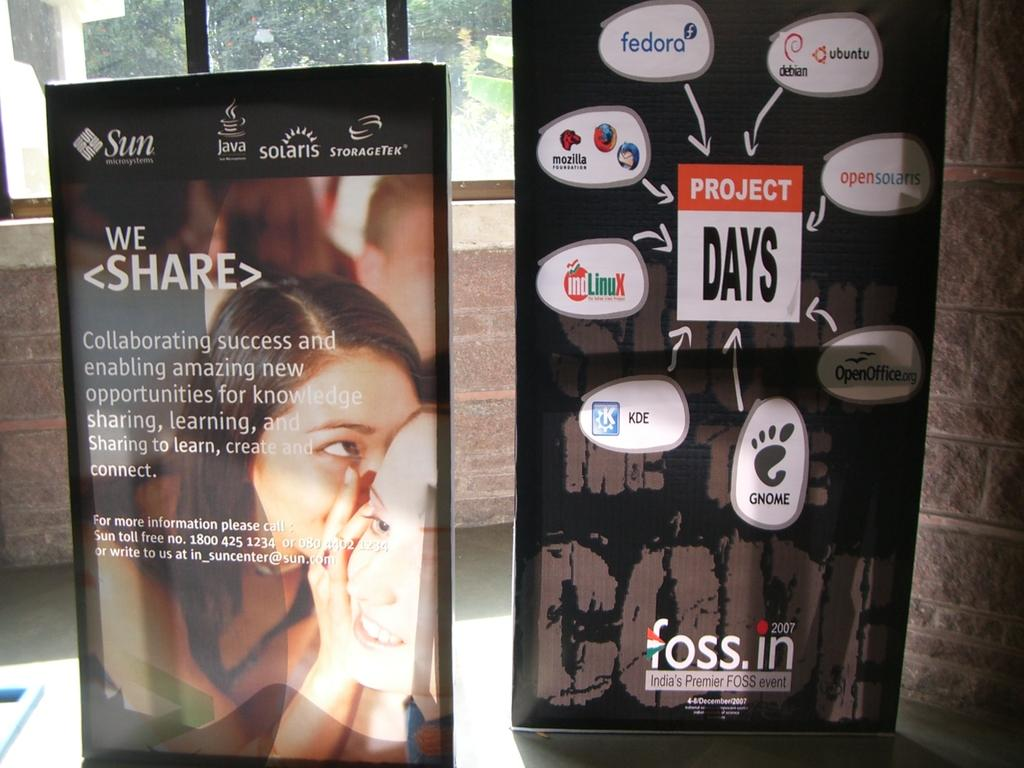What is the setting of the image? The image shows the inside of a house. What feature of the house is visible in the image? There is a glass window in the house. What can be seen outside the house in the image? Two hoardings are placed on a path near the house. What are the hoardings used for? The hoardings have advertisements on them. Can you see a fireman sliding down an icicle in the image? No, there is no fireman or icicle present in the image. 